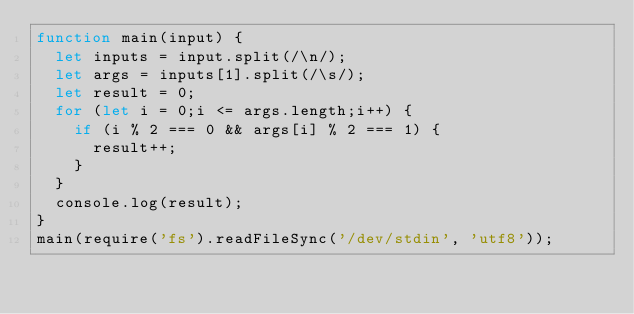Convert code to text. <code><loc_0><loc_0><loc_500><loc_500><_JavaScript_>function main(input) {
  let inputs = input.split(/\n/);
  let args = inputs[1].split(/\s/);
  let result = 0;
  for (let i = 0;i <= args.length;i++) {
    if (i % 2 === 0 && args[i] % 2 === 1) {
      result++;
    }
  }
  console.log(result);
}
main(require('fs').readFileSync('/dev/stdin', 'utf8'));</code> 